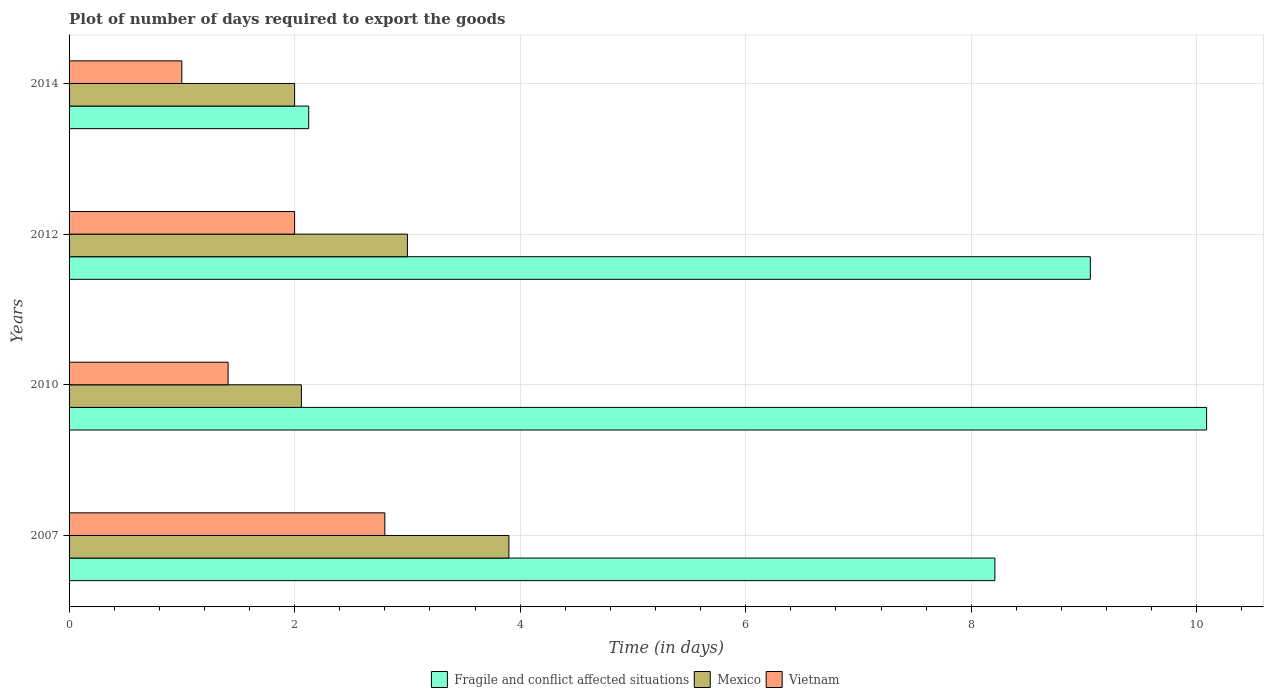How many different coloured bars are there?
Offer a terse response. 3. How many groups of bars are there?
Ensure brevity in your answer.  4. Are the number of bars on each tick of the Y-axis equal?
Keep it short and to the point. Yes. How many bars are there on the 1st tick from the bottom?
Offer a very short reply. 3. What is the time required to export goods in Vietnam in 2012?
Your response must be concise. 2. Across all years, what is the minimum time required to export goods in Mexico?
Provide a succinct answer. 2. In which year was the time required to export goods in Vietnam minimum?
Your answer should be compact. 2014. What is the total time required to export goods in Fragile and conflict affected situations in the graph?
Your answer should be compact. 29.48. What is the difference between the time required to export goods in Fragile and conflict affected situations in 2007 and that in 2014?
Your response must be concise. 6.08. What is the average time required to export goods in Mexico per year?
Your answer should be very brief. 2.74. In the year 2007, what is the difference between the time required to export goods in Fragile and conflict affected situations and time required to export goods in Vietnam?
Your response must be concise. 5.41. In how many years, is the time required to export goods in Mexico greater than 5.6 days?
Offer a terse response. 0. Is the difference between the time required to export goods in Fragile and conflict affected situations in 2012 and 2014 greater than the difference between the time required to export goods in Vietnam in 2012 and 2014?
Your answer should be compact. Yes. What is the difference between the highest and the second highest time required to export goods in Fragile and conflict affected situations?
Keep it short and to the point. 1.03. What is the difference between the highest and the lowest time required to export goods in Fragile and conflict affected situations?
Your answer should be very brief. 7.96. Is the sum of the time required to export goods in Vietnam in 2007 and 2012 greater than the maximum time required to export goods in Fragile and conflict affected situations across all years?
Provide a short and direct response. No. What does the 1st bar from the top in 2014 represents?
Offer a terse response. Vietnam. What does the 1st bar from the bottom in 2014 represents?
Provide a short and direct response. Fragile and conflict affected situations. Are all the bars in the graph horizontal?
Your response must be concise. Yes. How many years are there in the graph?
Ensure brevity in your answer.  4. What is the difference between two consecutive major ticks on the X-axis?
Provide a short and direct response. 2. Does the graph contain any zero values?
Provide a succinct answer. No. Does the graph contain grids?
Give a very brief answer. Yes. How many legend labels are there?
Ensure brevity in your answer.  3. How are the legend labels stacked?
Provide a short and direct response. Horizontal. What is the title of the graph?
Make the answer very short. Plot of number of days required to export the goods. Does "Venezuela" appear as one of the legend labels in the graph?
Offer a terse response. No. What is the label or title of the X-axis?
Your answer should be compact. Time (in days). What is the Time (in days) in Fragile and conflict affected situations in 2007?
Ensure brevity in your answer.  8.21. What is the Time (in days) of Vietnam in 2007?
Your answer should be very brief. 2.8. What is the Time (in days) in Fragile and conflict affected situations in 2010?
Provide a succinct answer. 10.09. What is the Time (in days) of Mexico in 2010?
Ensure brevity in your answer.  2.06. What is the Time (in days) of Vietnam in 2010?
Your answer should be compact. 1.41. What is the Time (in days) in Fragile and conflict affected situations in 2012?
Your response must be concise. 9.06. What is the Time (in days) of Fragile and conflict affected situations in 2014?
Provide a succinct answer. 2.12. What is the Time (in days) of Mexico in 2014?
Your response must be concise. 2. Across all years, what is the maximum Time (in days) of Fragile and conflict affected situations?
Keep it short and to the point. 10.09. Across all years, what is the maximum Time (in days) of Vietnam?
Your response must be concise. 2.8. Across all years, what is the minimum Time (in days) of Fragile and conflict affected situations?
Your response must be concise. 2.12. Across all years, what is the minimum Time (in days) of Mexico?
Ensure brevity in your answer.  2. What is the total Time (in days) of Fragile and conflict affected situations in the graph?
Ensure brevity in your answer.  29.48. What is the total Time (in days) of Mexico in the graph?
Make the answer very short. 10.96. What is the total Time (in days) of Vietnam in the graph?
Your response must be concise. 7.21. What is the difference between the Time (in days) in Fragile and conflict affected situations in 2007 and that in 2010?
Give a very brief answer. -1.88. What is the difference between the Time (in days) of Mexico in 2007 and that in 2010?
Offer a terse response. 1.84. What is the difference between the Time (in days) in Vietnam in 2007 and that in 2010?
Provide a succinct answer. 1.39. What is the difference between the Time (in days) of Fragile and conflict affected situations in 2007 and that in 2012?
Offer a terse response. -0.85. What is the difference between the Time (in days) in Mexico in 2007 and that in 2012?
Provide a short and direct response. 0.9. What is the difference between the Time (in days) of Vietnam in 2007 and that in 2012?
Provide a short and direct response. 0.8. What is the difference between the Time (in days) in Fragile and conflict affected situations in 2007 and that in 2014?
Offer a very short reply. 6.08. What is the difference between the Time (in days) in Mexico in 2007 and that in 2014?
Provide a succinct answer. 1.9. What is the difference between the Time (in days) in Vietnam in 2007 and that in 2014?
Give a very brief answer. 1.8. What is the difference between the Time (in days) in Fragile and conflict affected situations in 2010 and that in 2012?
Your response must be concise. 1.03. What is the difference between the Time (in days) in Mexico in 2010 and that in 2012?
Keep it short and to the point. -0.94. What is the difference between the Time (in days) in Vietnam in 2010 and that in 2012?
Your answer should be compact. -0.59. What is the difference between the Time (in days) in Fragile and conflict affected situations in 2010 and that in 2014?
Offer a very short reply. 7.96. What is the difference between the Time (in days) in Mexico in 2010 and that in 2014?
Offer a very short reply. 0.06. What is the difference between the Time (in days) in Vietnam in 2010 and that in 2014?
Provide a succinct answer. 0.41. What is the difference between the Time (in days) in Fragile and conflict affected situations in 2012 and that in 2014?
Ensure brevity in your answer.  6.93. What is the difference between the Time (in days) of Mexico in 2012 and that in 2014?
Keep it short and to the point. 1. What is the difference between the Time (in days) in Vietnam in 2012 and that in 2014?
Make the answer very short. 1. What is the difference between the Time (in days) of Fragile and conflict affected situations in 2007 and the Time (in days) of Mexico in 2010?
Provide a succinct answer. 6.15. What is the difference between the Time (in days) in Fragile and conflict affected situations in 2007 and the Time (in days) in Vietnam in 2010?
Your answer should be compact. 6.8. What is the difference between the Time (in days) in Mexico in 2007 and the Time (in days) in Vietnam in 2010?
Your answer should be very brief. 2.49. What is the difference between the Time (in days) in Fragile and conflict affected situations in 2007 and the Time (in days) in Mexico in 2012?
Offer a very short reply. 5.21. What is the difference between the Time (in days) of Fragile and conflict affected situations in 2007 and the Time (in days) of Vietnam in 2012?
Ensure brevity in your answer.  6.21. What is the difference between the Time (in days) of Fragile and conflict affected situations in 2007 and the Time (in days) of Mexico in 2014?
Your response must be concise. 6.21. What is the difference between the Time (in days) in Fragile and conflict affected situations in 2007 and the Time (in days) in Vietnam in 2014?
Your answer should be very brief. 7.21. What is the difference between the Time (in days) of Mexico in 2007 and the Time (in days) of Vietnam in 2014?
Offer a terse response. 2.9. What is the difference between the Time (in days) of Fragile and conflict affected situations in 2010 and the Time (in days) of Mexico in 2012?
Offer a terse response. 7.09. What is the difference between the Time (in days) of Fragile and conflict affected situations in 2010 and the Time (in days) of Vietnam in 2012?
Your response must be concise. 8.09. What is the difference between the Time (in days) of Mexico in 2010 and the Time (in days) of Vietnam in 2012?
Your answer should be compact. 0.06. What is the difference between the Time (in days) in Fragile and conflict affected situations in 2010 and the Time (in days) in Mexico in 2014?
Keep it short and to the point. 8.09. What is the difference between the Time (in days) of Fragile and conflict affected situations in 2010 and the Time (in days) of Vietnam in 2014?
Your response must be concise. 9.09. What is the difference between the Time (in days) in Mexico in 2010 and the Time (in days) in Vietnam in 2014?
Your answer should be very brief. 1.06. What is the difference between the Time (in days) in Fragile and conflict affected situations in 2012 and the Time (in days) in Mexico in 2014?
Give a very brief answer. 7.06. What is the difference between the Time (in days) in Fragile and conflict affected situations in 2012 and the Time (in days) in Vietnam in 2014?
Make the answer very short. 8.06. What is the difference between the Time (in days) in Mexico in 2012 and the Time (in days) in Vietnam in 2014?
Offer a very short reply. 2. What is the average Time (in days) in Fragile and conflict affected situations per year?
Provide a short and direct response. 7.37. What is the average Time (in days) of Mexico per year?
Provide a short and direct response. 2.74. What is the average Time (in days) of Vietnam per year?
Offer a very short reply. 1.8. In the year 2007, what is the difference between the Time (in days) in Fragile and conflict affected situations and Time (in days) in Mexico?
Give a very brief answer. 4.31. In the year 2007, what is the difference between the Time (in days) of Fragile and conflict affected situations and Time (in days) of Vietnam?
Keep it short and to the point. 5.41. In the year 2007, what is the difference between the Time (in days) of Mexico and Time (in days) of Vietnam?
Ensure brevity in your answer.  1.1. In the year 2010, what is the difference between the Time (in days) of Fragile and conflict affected situations and Time (in days) of Mexico?
Your answer should be compact. 8.03. In the year 2010, what is the difference between the Time (in days) in Fragile and conflict affected situations and Time (in days) in Vietnam?
Offer a terse response. 8.68. In the year 2010, what is the difference between the Time (in days) in Mexico and Time (in days) in Vietnam?
Provide a short and direct response. 0.65. In the year 2012, what is the difference between the Time (in days) of Fragile and conflict affected situations and Time (in days) of Mexico?
Offer a very short reply. 6.06. In the year 2012, what is the difference between the Time (in days) of Fragile and conflict affected situations and Time (in days) of Vietnam?
Your answer should be very brief. 7.06. In the year 2012, what is the difference between the Time (in days) of Mexico and Time (in days) of Vietnam?
Keep it short and to the point. 1. In the year 2014, what is the difference between the Time (in days) of Mexico and Time (in days) of Vietnam?
Provide a short and direct response. 1. What is the ratio of the Time (in days) of Fragile and conflict affected situations in 2007 to that in 2010?
Your answer should be very brief. 0.81. What is the ratio of the Time (in days) of Mexico in 2007 to that in 2010?
Offer a very short reply. 1.89. What is the ratio of the Time (in days) in Vietnam in 2007 to that in 2010?
Make the answer very short. 1.99. What is the ratio of the Time (in days) of Fragile and conflict affected situations in 2007 to that in 2012?
Give a very brief answer. 0.91. What is the ratio of the Time (in days) of Vietnam in 2007 to that in 2012?
Your answer should be compact. 1.4. What is the ratio of the Time (in days) in Fragile and conflict affected situations in 2007 to that in 2014?
Make the answer very short. 3.86. What is the ratio of the Time (in days) of Mexico in 2007 to that in 2014?
Provide a succinct answer. 1.95. What is the ratio of the Time (in days) of Fragile and conflict affected situations in 2010 to that in 2012?
Your response must be concise. 1.11. What is the ratio of the Time (in days) of Mexico in 2010 to that in 2012?
Give a very brief answer. 0.69. What is the ratio of the Time (in days) of Vietnam in 2010 to that in 2012?
Make the answer very short. 0.7. What is the ratio of the Time (in days) in Fragile and conflict affected situations in 2010 to that in 2014?
Give a very brief answer. 4.75. What is the ratio of the Time (in days) of Mexico in 2010 to that in 2014?
Give a very brief answer. 1.03. What is the ratio of the Time (in days) of Vietnam in 2010 to that in 2014?
Make the answer very short. 1.41. What is the ratio of the Time (in days) in Fragile and conflict affected situations in 2012 to that in 2014?
Provide a succinct answer. 4.26. What is the difference between the highest and the second highest Time (in days) of Fragile and conflict affected situations?
Give a very brief answer. 1.03. What is the difference between the highest and the second highest Time (in days) in Mexico?
Your response must be concise. 0.9. What is the difference between the highest and the second highest Time (in days) of Vietnam?
Provide a succinct answer. 0.8. What is the difference between the highest and the lowest Time (in days) in Fragile and conflict affected situations?
Give a very brief answer. 7.96. What is the difference between the highest and the lowest Time (in days) in Vietnam?
Your answer should be very brief. 1.8. 